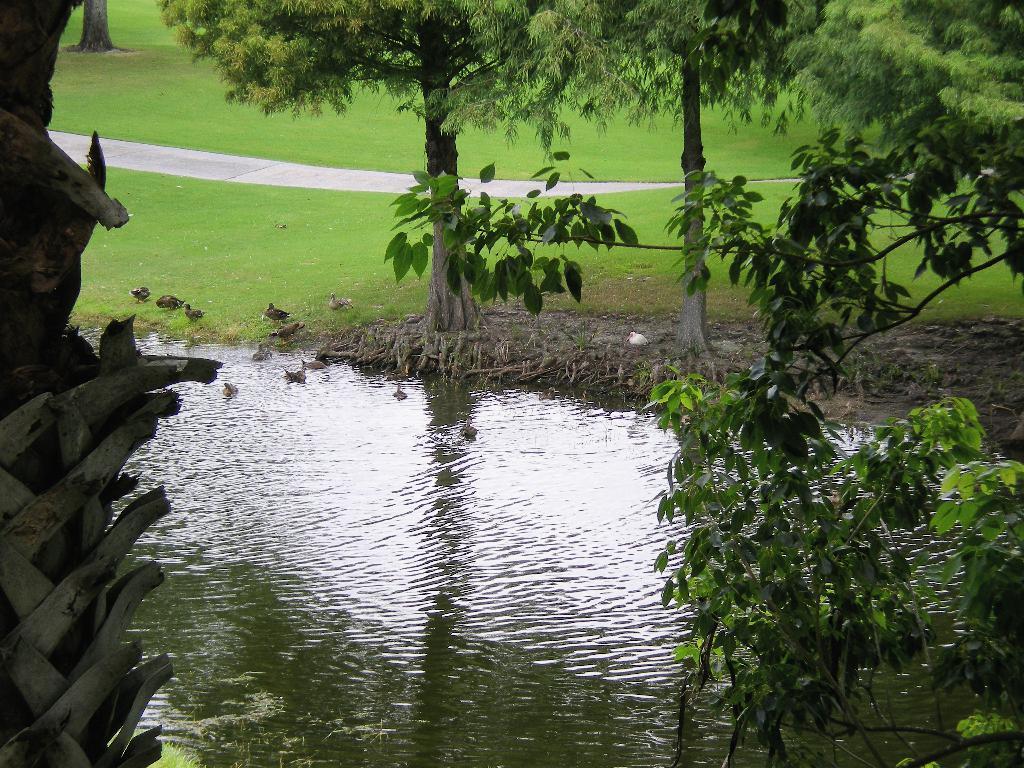Please provide a concise description of this image. In the foreground of this image, there is water and few trees around it. We can also see few birds on the grass and in the water. In the background, there is a grassland, path and the tree trunk. 